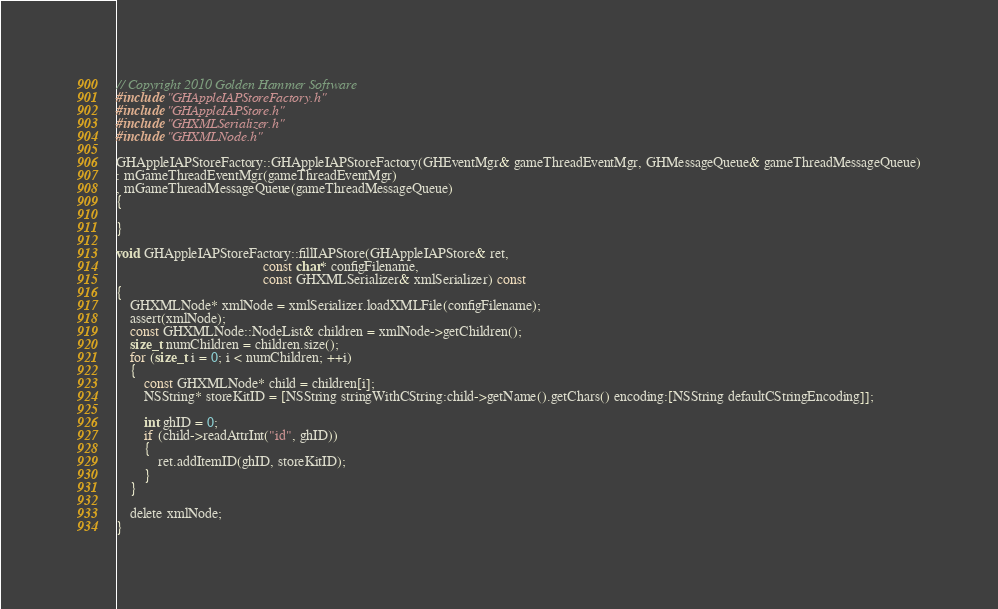Convert code to text. <code><loc_0><loc_0><loc_500><loc_500><_ObjectiveC_>// Copyright 2010 Golden Hammer Software
#include "GHAppleIAPStoreFactory.h"
#include "GHAppleIAPStore.h"
#include "GHXMLSerializer.h"
#include "GHXMLNode.h"

GHAppleIAPStoreFactory::GHAppleIAPStoreFactory(GHEventMgr& gameThreadEventMgr, GHMessageQueue& gameThreadMessageQueue)
: mGameThreadEventMgr(gameThreadEventMgr)
, mGameThreadMessageQueue(gameThreadMessageQueue)
{
   
}

void GHAppleIAPStoreFactory::fillIAPStore(GHAppleIAPStore& ret,
                                          const char* configFilename,
                                          const GHXMLSerializer& xmlSerializer) const
{
    GHXMLNode* xmlNode = xmlSerializer.loadXMLFile(configFilename);
    assert(xmlNode);
    const GHXMLNode::NodeList& children = xmlNode->getChildren();
    size_t numChildren = children.size();
    for (size_t i = 0; i < numChildren; ++i)
    {
        const GHXMLNode* child = children[i];
        NSString* storeKitID = [NSString stringWithCString:child->getName().getChars() encoding:[NSString defaultCStringEncoding]];
        
        int ghID = 0;
        if (child->readAttrInt("id", ghID))
        {
            ret.addItemID(ghID, storeKitID);
        }
    }
    
    delete xmlNode;
}
</code> 